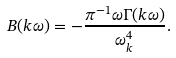<formula> <loc_0><loc_0><loc_500><loc_500>B ( { k } \omega ) = - \frac { \pi ^ { - 1 } \omega \Gamma ( { k } \omega ) } { \omega ^ { 4 } _ { k } } .</formula> 